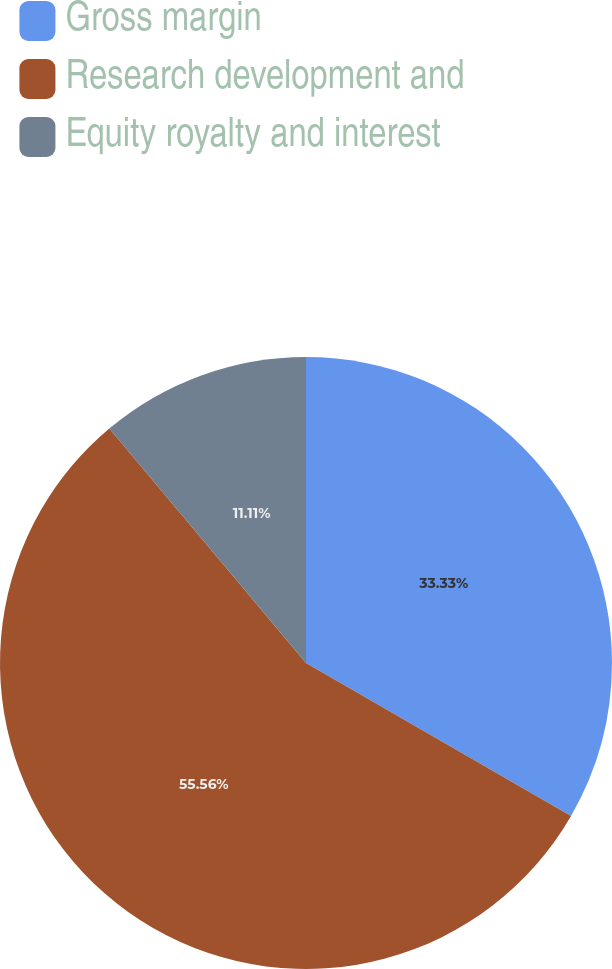Convert chart. <chart><loc_0><loc_0><loc_500><loc_500><pie_chart><fcel>Gross margin<fcel>Research development and<fcel>Equity royalty and interest<nl><fcel>33.33%<fcel>55.56%<fcel>11.11%<nl></chart> 